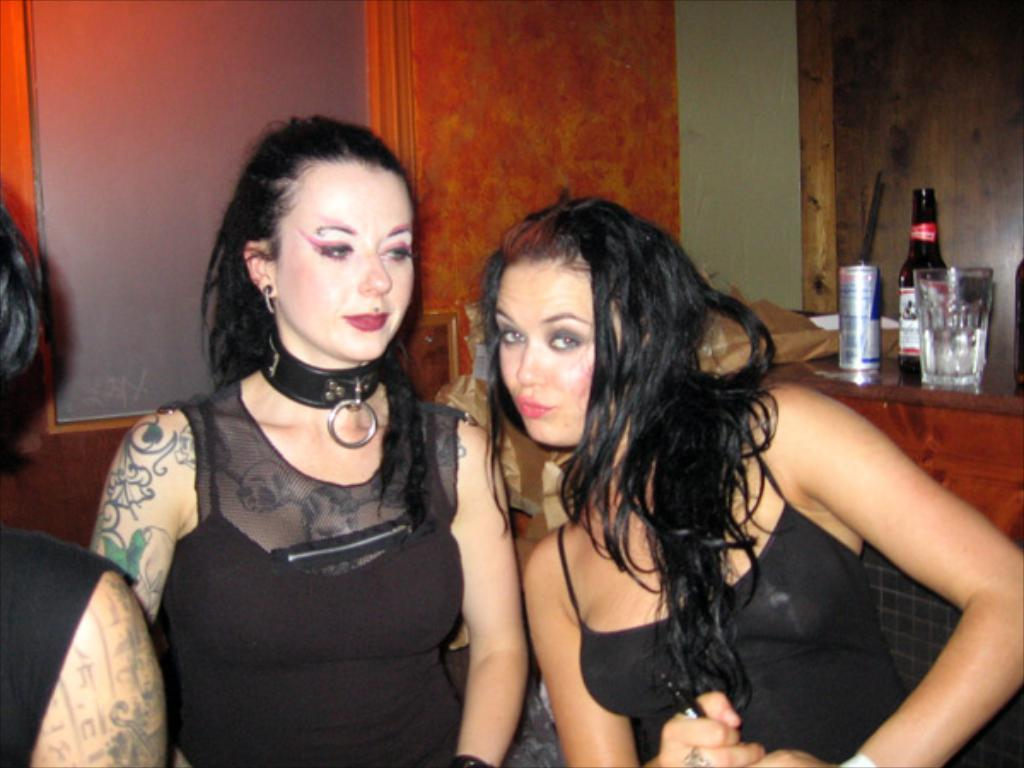How many people are in the image? There are three persons in the image. What is the gender of the majority of the people in the image? Two of the persons are women. What is the facial expression of the women in the image? The women are smiling. What objects can be seen in the background of the image? There is a bottle, a tin, a glass, and a wall in the background of the image. What type of flame can be seen on the leg of one of the women in the image? There is no flame or leg visible on any of the women in the image. 